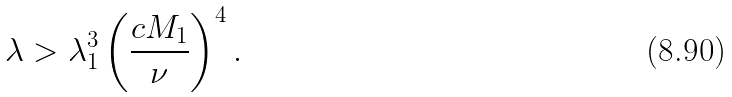Convert formula to latex. <formula><loc_0><loc_0><loc_500><loc_500>\lambda > \lambda _ { 1 } ^ { 3 } \left ( \frac { c M _ { 1 } } { \nu } \right ) ^ { 4 } .</formula> 